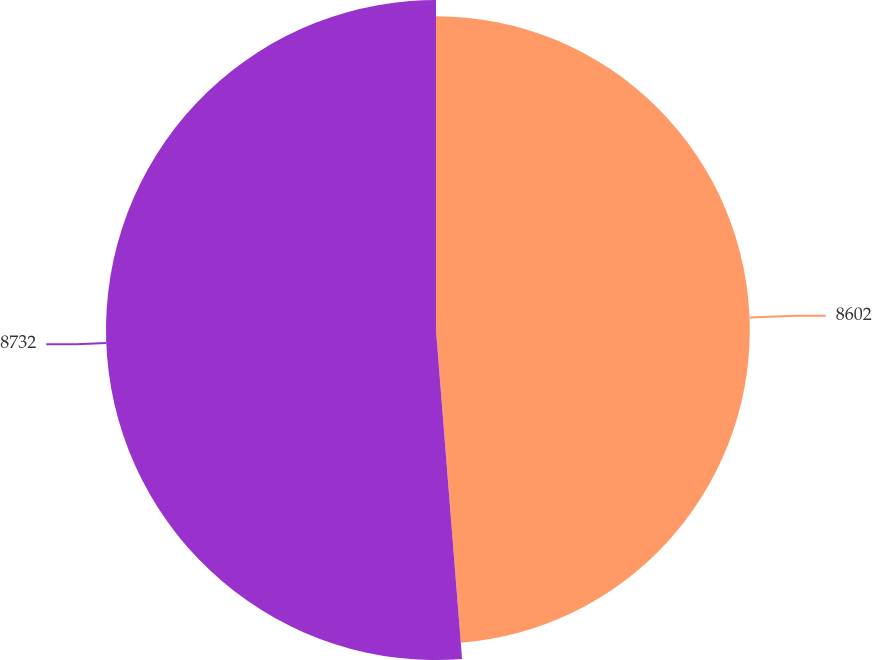Convert chart to OTSL. <chart><loc_0><loc_0><loc_500><loc_500><pie_chart><fcel>8602<fcel>8732<nl><fcel>48.74%<fcel>51.26%<nl></chart> 